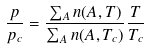Convert formula to latex. <formula><loc_0><loc_0><loc_500><loc_500>\frac { p } { p _ { c } } = \frac { \sum _ { A } n ( A , T ) } { \sum _ { A } n ( A , T _ { c } ) } \frac { T } { T _ { c } }</formula> 